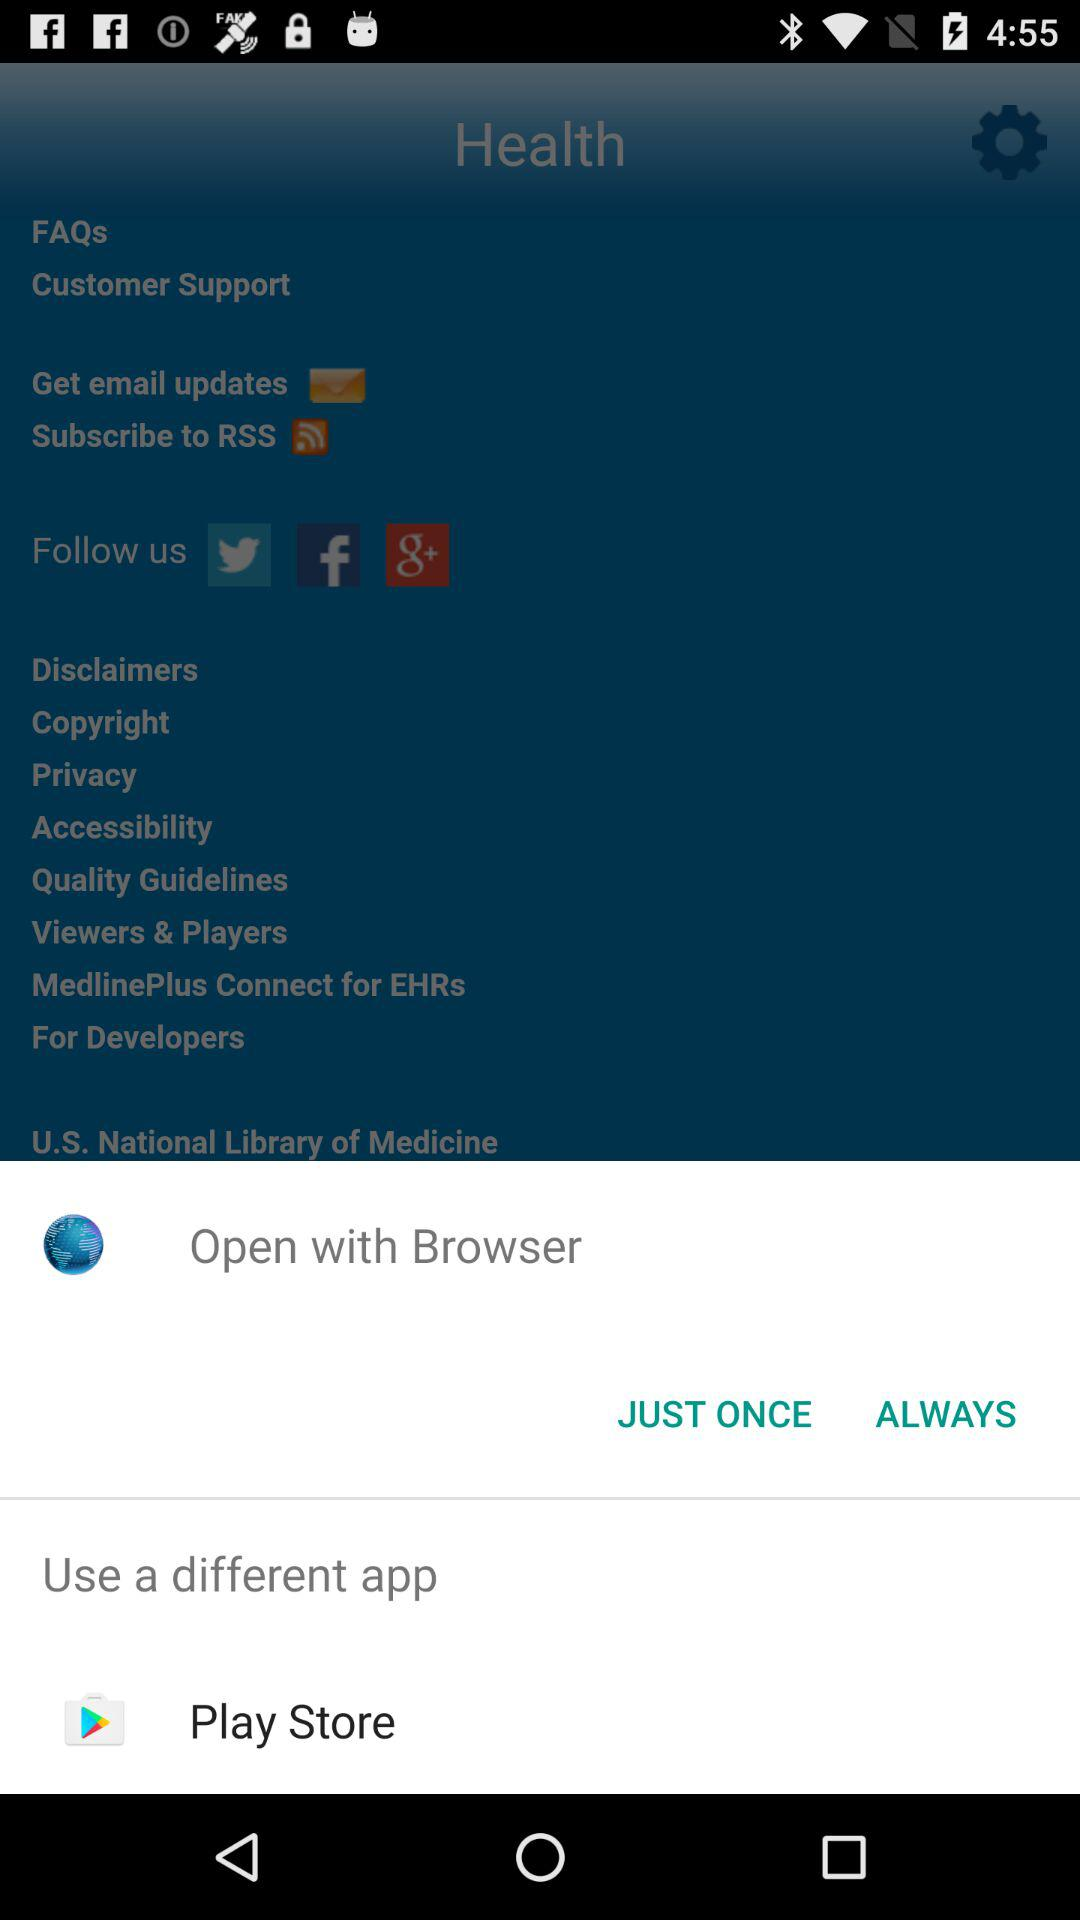What application can I use to open the content? The application is "Browser". 